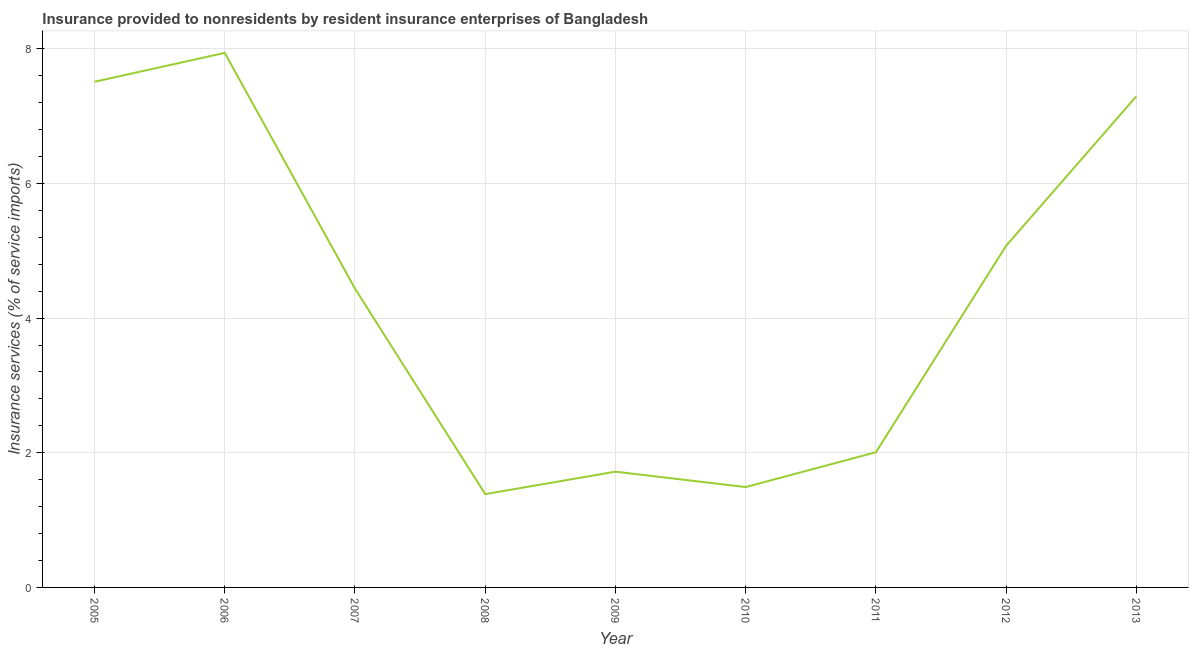What is the insurance and financial services in 2012?
Your response must be concise. 5.08. Across all years, what is the maximum insurance and financial services?
Provide a succinct answer. 7.94. Across all years, what is the minimum insurance and financial services?
Make the answer very short. 1.39. In which year was the insurance and financial services minimum?
Provide a short and direct response. 2008. What is the sum of the insurance and financial services?
Your answer should be compact. 38.86. What is the difference between the insurance and financial services in 2010 and 2011?
Offer a terse response. -0.52. What is the average insurance and financial services per year?
Your answer should be compact. 4.32. What is the median insurance and financial services?
Your answer should be very brief. 4.44. In how many years, is the insurance and financial services greater than 1.6 %?
Make the answer very short. 7. What is the ratio of the insurance and financial services in 2006 to that in 2009?
Your response must be concise. 4.62. Is the insurance and financial services in 2008 less than that in 2010?
Provide a succinct answer. Yes. What is the difference between the highest and the second highest insurance and financial services?
Provide a short and direct response. 0.43. What is the difference between the highest and the lowest insurance and financial services?
Make the answer very short. 6.55. Does the insurance and financial services monotonically increase over the years?
Your answer should be compact. No. How many lines are there?
Offer a terse response. 1. How many years are there in the graph?
Keep it short and to the point. 9. Does the graph contain grids?
Offer a very short reply. Yes. What is the title of the graph?
Offer a terse response. Insurance provided to nonresidents by resident insurance enterprises of Bangladesh. What is the label or title of the Y-axis?
Keep it short and to the point. Insurance services (% of service imports). What is the Insurance services (% of service imports) in 2005?
Your response must be concise. 7.51. What is the Insurance services (% of service imports) in 2006?
Your response must be concise. 7.94. What is the Insurance services (% of service imports) of 2007?
Offer a very short reply. 4.44. What is the Insurance services (% of service imports) of 2008?
Give a very brief answer. 1.39. What is the Insurance services (% of service imports) of 2009?
Offer a terse response. 1.72. What is the Insurance services (% of service imports) of 2010?
Offer a very short reply. 1.49. What is the Insurance services (% of service imports) in 2011?
Offer a very short reply. 2.01. What is the Insurance services (% of service imports) in 2012?
Give a very brief answer. 5.08. What is the Insurance services (% of service imports) of 2013?
Your answer should be compact. 7.3. What is the difference between the Insurance services (% of service imports) in 2005 and 2006?
Give a very brief answer. -0.43. What is the difference between the Insurance services (% of service imports) in 2005 and 2007?
Provide a short and direct response. 3.07. What is the difference between the Insurance services (% of service imports) in 2005 and 2008?
Give a very brief answer. 6.12. What is the difference between the Insurance services (% of service imports) in 2005 and 2009?
Make the answer very short. 5.79. What is the difference between the Insurance services (% of service imports) in 2005 and 2010?
Ensure brevity in your answer.  6.02. What is the difference between the Insurance services (% of service imports) in 2005 and 2011?
Provide a short and direct response. 5.5. What is the difference between the Insurance services (% of service imports) in 2005 and 2012?
Make the answer very short. 2.43. What is the difference between the Insurance services (% of service imports) in 2005 and 2013?
Make the answer very short. 0.21. What is the difference between the Insurance services (% of service imports) in 2006 and 2007?
Give a very brief answer. 3.5. What is the difference between the Insurance services (% of service imports) in 2006 and 2008?
Provide a short and direct response. 6.55. What is the difference between the Insurance services (% of service imports) in 2006 and 2009?
Your answer should be compact. 6.22. What is the difference between the Insurance services (% of service imports) in 2006 and 2010?
Make the answer very short. 6.45. What is the difference between the Insurance services (% of service imports) in 2006 and 2011?
Provide a short and direct response. 5.93. What is the difference between the Insurance services (% of service imports) in 2006 and 2012?
Ensure brevity in your answer.  2.86. What is the difference between the Insurance services (% of service imports) in 2006 and 2013?
Offer a terse response. 0.64. What is the difference between the Insurance services (% of service imports) in 2007 and 2008?
Ensure brevity in your answer.  3.05. What is the difference between the Insurance services (% of service imports) in 2007 and 2009?
Provide a succinct answer. 2.72. What is the difference between the Insurance services (% of service imports) in 2007 and 2010?
Your answer should be very brief. 2.95. What is the difference between the Insurance services (% of service imports) in 2007 and 2011?
Provide a succinct answer. 2.43. What is the difference between the Insurance services (% of service imports) in 2007 and 2012?
Give a very brief answer. -0.64. What is the difference between the Insurance services (% of service imports) in 2007 and 2013?
Make the answer very short. -2.86. What is the difference between the Insurance services (% of service imports) in 2008 and 2009?
Offer a terse response. -0.33. What is the difference between the Insurance services (% of service imports) in 2008 and 2010?
Your answer should be compact. -0.11. What is the difference between the Insurance services (% of service imports) in 2008 and 2011?
Your answer should be compact. -0.62. What is the difference between the Insurance services (% of service imports) in 2008 and 2012?
Your answer should be very brief. -3.69. What is the difference between the Insurance services (% of service imports) in 2008 and 2013?
Provide a short and direct response. -5.91. What is the difference between the Insurance services (% of service imports) in 2009 and 2010?
Make the answer very short. 0.23. What is the difference between the Insurance services (% of service imports) in 2009 and 2011?
Your answer should be compact. -0.29. What is the difference between the Insurance services (% of service imports) in 2009 and 2012?
Give a very brief answer. -3.36. What is the difference between the Insurance services (% of service imports) in 2009 and 2013?
Make the answer very short. -5.58. What is the difference between the Insurance services (% of service imports) in 2010 and 2011?
Your answer should be compact. -0.52. What is the difference between the Insurance services (% of service imports) in 2010 and 2012?
Keep it short and to the point. -3.59. What is the difference between the Insurance services (% of service imports) in 2010 and 2013?
Ensure brevity in your answer.  -5.81. What is the difference between the Insurance services (% of service imports) in 2011 and 2012?
Provide a short and direct response. -3.07. What is the difference between the Insurance services (% of service imports) in 2011 and 2013?
Ensure brevity in your answer.  -5.29. What is the difference between the Insurance services (% of service imports) in 2012 and 2013?
Ensure brevity in your answer.  -2.22. What is the ratio of the Insurance services (% of service imports) in 2005 to that in 2006?
Give a very brief answer. 0.95. What is the ratio of the Insurance services (% of service imports) in 2005 to that in 2007?
Your answer should be very brief. 1.69. What is the ratio of the Insurance services (% of service imports) in 2005 to that in 2008?
Offer a very short reply. 5.42. What is the ratio of the Insurance services (% of service imports) in 2005 to that in 2009?
Provide a succinct answer. 4.37. What is the ratio of the Insurance services (% of service imports) in 2005 to that in 2010?
Ensure brevity in your answer.  5.04. What is the ratio of the Insurance services (% of service imports) in 2005 to that in 2011?
Give a very brief answer. 3.74. What is the ratio of the Insurance services (% of service imports) in 2005 to that in 2012?
Make the answer very short. 1.48. What is the ratio of the Insurance services (% of service imports) in 2005 to that in 2013?
Your answer should be compact. 1.03. What is the ratio of the Insurance services (% of service imports) in 2006 to that in 2007?
Ensure brevity in your answer.  1.79. What is the ratio of the Insurance services (% of service imports) in 2006 to that in 2008?
Offer a very short reply. 5.73. What is the ratio of the Insurance services (% of service imports) in 2006 to that in 2009?
Keep it short and to the point. 4.62. What is the ratio of the Insurance services (% of service imports) in 2006 to that in 2010?
Make the answer very short. 5.33. What is the ratio of the Insurance services (% of service imports) in 2006 to that in 2011?
Your response must be concise. 3.95. What is the ratio of the Insurance services (% of service imports) in 2006 to that in 2012?
Ensure brevity in your answer.  1.56. What is the ratio of the Insurance services (% of service imports) in 2006 to that in 2013?
Your answer should be compact. 1.09. What is the ratio of the Insurance services (% of service imports) in 2007 to that in 2008?
Give a very brief answer. 3.2. What is the ratio of the Insurance services (% of service imports) in 2007 to that in 2009?
Provide a short and direct response. 2.58. What is the ratio of the Insurance services (% of service imports) in 2007 to that in 2010?
Keep it short and to the point. 2.98. What is the ratio of the Insurance services (% of service imports) in 2007 to that in 2011?
Provide a short and direct response. 2.21. What is the ratio of the Insurance services (% of service imports) in 2007 to that in 2013?
Your answer should be very brief. 0.61. What is the ratio of the Insurance services (% of service imports) in 2008 to that in 2009?
Offer a very short reply. 0.81. What is the ratio of the Insurance services (% of service imports) in 2008 to that in 2010?
Your response must be concise. 0.93. What is the ratio of the Insurance services (% of service imports) in 2008 to that in 2011?
Offer a terse response. 0.69. What is the ratio of the Insurance services (% of service imports) in 2008 to that in 2012?
Give a very brief answer. 0.27. What is the ratio of the Insurance services (% of service imports) in 2008 to that in 2013?
Your answer should be very brief. 0.19. What is the ratio of the Insurance services (% of service imports) in 2009 to that in 2010?
Provide a succinct answer. 1.15. What is the ratio of the Insurance services (% of service imports) in 2009 to that in 2011?
Your response must be concise. 0.86. What is the ratio of the Insurance services (% of service imports) in 2009 to that in 2012?
Your answer should be very brief. 0.34. What is the ratio of the Insurance services (% of service imports) in 2009 to that in 2013?
Your response must be concise. 0.24. What is the ratio of the Insurance services (% of service imports) in 2010 to that in 2011?
Keep it short and to the point. 0.74. What is the ratio of the Insurance services (% of service imports) in 2010 to that in 2012?
Your answer should be compact. 0.29. What is the ratio of the Insurance services (% of service imports) in 2010 to that in 2013?
Offer a terse response. 0.2. What is the ratio of the Insurance services (% of service imports) in 2011 to that in 2012?
Provide a short and direct response. 0.4. What is the ratio of the Insurance services (% of service imports) in 2011 to that in 2013?
Give a very brief answer. 0.28. What is the ratio of the Insurance services (% of service imports) in 2012 to that in 2013?
Keep it short and to the point. 0.7. 